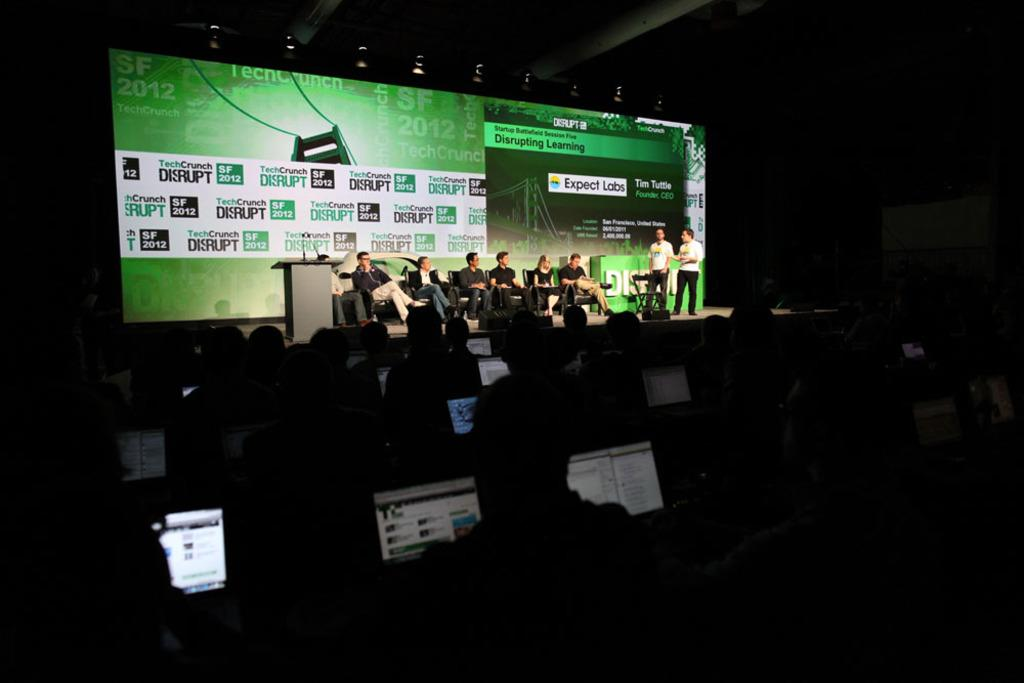What objects are present in the image that are used for displaying information? There are screens in the image. What type of furniture is visible in the image? There are chairs in the image. Can you describe the people in the image? There is a group of people in the image. What objects are present in the image that are used for amplifying sound? There are microphones (mics) in the image. How would you describe the lighting in the image? The image appears to be slightly dark. Reasoning: Let' Let's think step by step in order to produce the conversation. We start by identifying the main objects in the image, which are the screens and chairs. Then, we describe the people present in the image and the purpose of the microphones. Finally, we mention the lighting condition of the image. Each question is designed to elicit a specific detail about the image that is known from the provided facts. Absurd Question/Answer: What type of protest is taking place in the image? There is no protest present in the image; it features screens, chairs, a group of people, and microphones in a slightly dark setting. What is the cause of death for the person in the image? There is no person in the image who appears to be deceased. The image features screens, chairs, a group of people, and microphones in a slightly dark setting. 